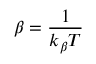Convert formula to latex. <formula><loc_0><loc_0><loc_500><loc_500>\beta = \frac { 1 } { k _ { \beta } T }</formula> 